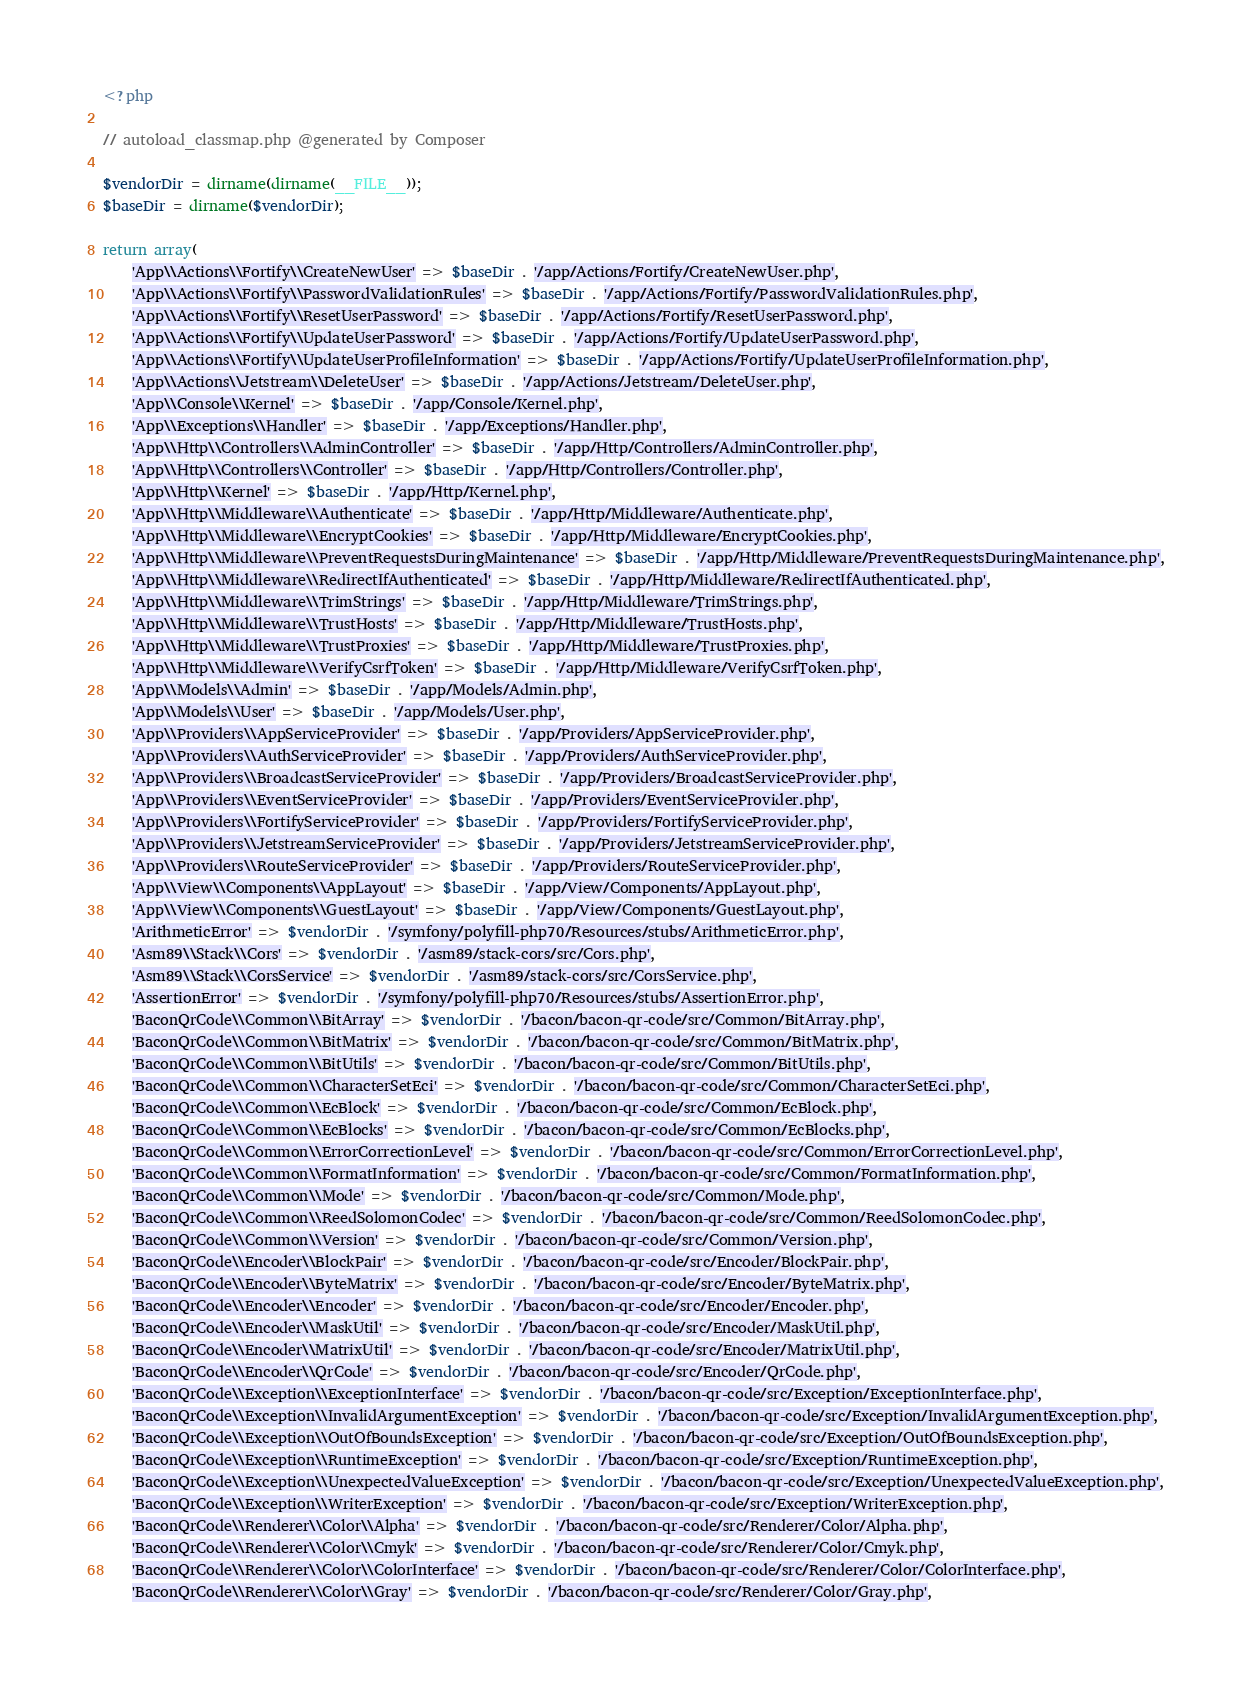<code> <loc_0><loc_0><loc_500><loc_500><_PHP_><?php

// autoload_classmap.php @generated by Composer

$vendorDir = dirname(dirname(__FILE__));
$baseDir = dirname($vendorDir);

return array(
    'App\\Actions\\Fortify\\CreateNewUser' => $baseDir . '/app/Actions/Fortify/CreateNewUser.php',
    'App\\Actions\\Fortify\\PasswordValidationRules' => $baseDir . '/app/Actions/Fortify/PasswordValidationRules.php',
    'App\\Actions\\Fortify\\ResetUserPassword' => $baseDir . '/app/Actions/Fortify/ResetUserPassword.php',
    'App\\Actions\\Fortify\\UpdateUserPassword' => $baseDir . '/app/Actions/Fortify/UpdateUserPassword.php',
    'App\\Actions\\Fortify\\UpdateUserProfileInformation' => $baseDir . '/app/Actions/Fortify/UpdateUserProfileInformation.php',
    'App\\Actions\\Jetstream\\DeleteUser' => $baseDir . '/app/Actions/Jetstream/DeleteUser.php',
    'App\\Console\\Kernel' => $baseDir . '/app/Console/Kernel.php',
    'App\\Exceptions\\Handler' => $baseDir . '/app/Exceptions/Handler.php',
    'App\\Http\\Controllers\\AdminController' => $baseDir . '/app/Http/Controllers/AdminController.php',
    'App\\Http\\Controllers\\Controller' => $baseDir . '/app/Http/Controllers/Controller.php',
    'App\\Http\\Kernel' => $baseDir . '/app/Http/Kernel.php',
    'App\\Http\\Middleware\\Authenticate' => $baseDir . '/app/Http/Middleware/Authenticate.php',
    'App\\Http\\Middleware\\EncryptCookies' => $baseDir . '/app/Http/Middleware/EncryptCookies.php',
    'App\\Http\\Middleware\\PreventRequestsDuringMaintenance' => $baseDir . '/app/Http/Middleware/PreventRequestsDuringMaintenance.php',
    'App\\Http\\Middleware\\RedirectIfAuthenticated' => $baseDir . '/app/Http/Middleware/RedirectIfAuthenticated.php',
    'App\\Http\\Middleware\\TrimStrings' => $baseDir . '/app/Http/Middleware/TrimStrings.php',
    'App\\Http\\Middleware\\TrustHosts' => $baseDir . '/app/Http/Middleware/TrustHosts.php',
    'App\\Http\\Middleware\\TrustProxies' => $baseDir . '/app/Http/Middleware/TrustProxies.php',
    'App\\Http\\Middleware\\VerifyCsrfToken' => $baseDir . '/app/Http/Middleware/VerifyCsrfToken.php',
    'App\\Models\\Admin' => $baseDir . '/app/Models/Admin.php',
    'App\\Models\\User' => $baseDir . '/app/Models/User.php',
    'App\\Providers\\AppServiceProvider' => $baseDir . '/app/Providers/AppServiceProvider.php',
    'App\\Providers\\AuthServiceProvider' => $baseDir . '/app/Providers/AuthServiceProvider.php',
    'App\\Providers\\BroadcastServiceProvider' => $baseDir . '/app/Providers/BroadcastServiceProvider.php',
    'App\\Providers\\EventServiceProvider' => $baseDir . '/app/Providers/EventServiceProvider.php',
    'App\\Providers\\FortifyServiceProvider' => $baseDir . '/app/Providers/FortifyServiceProvider.php',
    'App\\Providers\\JetstreamServiceProvider' => $baseDir . '/app/Providers/JetstreamServiceProvider.php',
    'App\\Providers\\RouteServiceProvider' => $baseDir . '/app/Providers/RouteServiceProvider.php',
    'App\\View\\Components\\AppLayout' => $baseDir . '/app/View/Components/AppLayout.php',
    'App\\View\\Components\\GuestLayout' => $baseDir . '/app/View/Components/GuestLayout.php',
    'ArithmeticError' => $vendorDir . '/symfony/polyfill-php70/Resources/stubs/ArithmeticError.php',
    'Asm89\\Stack\\Cors' => $vendorDir . '/asm89/stack-cors/src/Cors.php',
    'Asm89\\Stack\\CorsService' => $vendorDir . '/asm89/stack-cors/src/CorsService.php',
    'AssertionError' => $vendorDir . '/symfony/polyfill-php70/Resources/stubs/AssertionError.php',
    'BaconQrCode\\Common\\BitArray' => $vendorDir . '/bacon/bacon-qr-code/src/Common/BitArray.php',
    'BaconQrCode\\Common\\BitMatrix' => $vendorDir . '/bacon/bacon-qr-code/src/Common/BitMatrix.php',
    'BaconQrCode\\Common\\BitUtils' => $vendorDir . '/bacon/bacon-qr-code/src/Common/BitUtils.php',
    'BaconQrCode\\Common\\CharacterSetEci' => $vendorDir . '/bacon/bacon-qr-code/src/Common/CharacterSetEci.php',
    'BaconQrCode\\Common\\EcBlock' => $vendorDir . '/bacon/bacon-qr-code/src/Common/EcBlock.php',
    'BaconQrCode\\Common\\EcBlocks' => $vendorDir . '/bacon/bacon-qr-code/src/Common/EcBlocks.php',
    'BaconQrCode\\Common\\ErrorCorrectionLevel' => $vendorDir . '/bacon/bacon-qr-code/src/Common/ErrorCorrectionLevel.php',
    'BaconQrCode\\Common\\FormatInformation' => $vendorDir . '/bacon/bacon-qr-code/src/Common/FormatInformation.php',
    'BaconQrCode\\Common\\Mode' => $vendorDir . '/bacon/bacon-qr-code/src/Common/Mode.php',
    'BaconQrCode\\Common\\ReedSolomonCodec' => $vendorDir . '/bacon/bacon-qr-code/src/Common/ReedSolomonCodec.php',
    'BaconQrCode\\Common\\Version' => $vendorDir . '/bacon/bacon-qr-code/src/Common/Version.php',
    'BaconQrCode\\Encoder\\BlockPair' => $vendorDir . '/bacon/bacon-qr-code/src/Encoder/BlockPair.php',
    'BaconQrCode\\Encoder\\ByteMatrix' => $vendorDir . '/bacon/bacon-qr-code/src/Encoder/ByteMatrix.php',
    'BaconQrCode\\Encoder\\Encoder' => $vendorDir . '/bacon/bacon-qr-code/src/Encoder/Encoder.php',
    'BaconQrCode\\Encoder\\MaskUtil' => $vendorDir . '/bacon/bacon-qr-code/src/Encoder/MaskUtil.php',
    'BaconQrCode\\Encoder\\MatrixUtil' => $vendorDir . '/bacon/bacon-qr-code/src/Encoder/MatrixUtil.php',
    'BaconQrCode\\Encoder\\QrCode' => $vendorDir . '/bacon/bacon-qr-code/src/Encoder/QrCode.php',
    'BaconQrCode\\Exception\\ExceptionInterface' => $vendorDir . '/bacon/bacon-qr-code/src/Exception/ExceptionInterface.php',
    'BaconQrCode\\Exception\\InvalidArgumentException' => $vendorDir . '/bacon/bacon-qr-code/src/Exception/InvalidArgumentException.php',
    'BaconQrCode\\Exception\\OutOfBoundsException' => $vendorDir . '/bacon/bacon-qr-code/src/Exception/OutOfBoundsException.php',
    'BaconQrCode\\Exception\\RuntimeException' => $vendorDir . '/bacon/bacon-qr-code/src/Exception/RuntimeException.php',
    'BaconQrCode\\Exception\\UnexpectedValueException' => $vendorDir . '/bacon/bacon-qr-code/src/Exception/UnexpectedValueException.php',
    'BaconQrCode\\Exception\\WriterException' => $vendorDir . '/bacon/bacon-qr-code/src/Exception/WriterException.php',
    'BaconQrCode\\Renderer\\Color\\Alpha' => $vendorDir . '/bacon/bacon-qr-code/src/Renderer/Color/Alpha.php',
    'BaconQrCode\\Renderer\\Color\\Cmyk' => $vendorDir . '/bacon/bacon-qr-code/src/Renderer/Color/Cmyk.php',
    'BaconQrCode\\Renderer\\Color\\ColorInterface' => $vendorDir . '/bacon/bacon-qr-code/src/Renderer/Color/ColorInterface.php',
    'BaconQrCode\\Renderer\\Color\\Gray' => $vendorDir . '/bacon/bacon-qr-code/src/Renderer/Color/Gray.php',</code> 